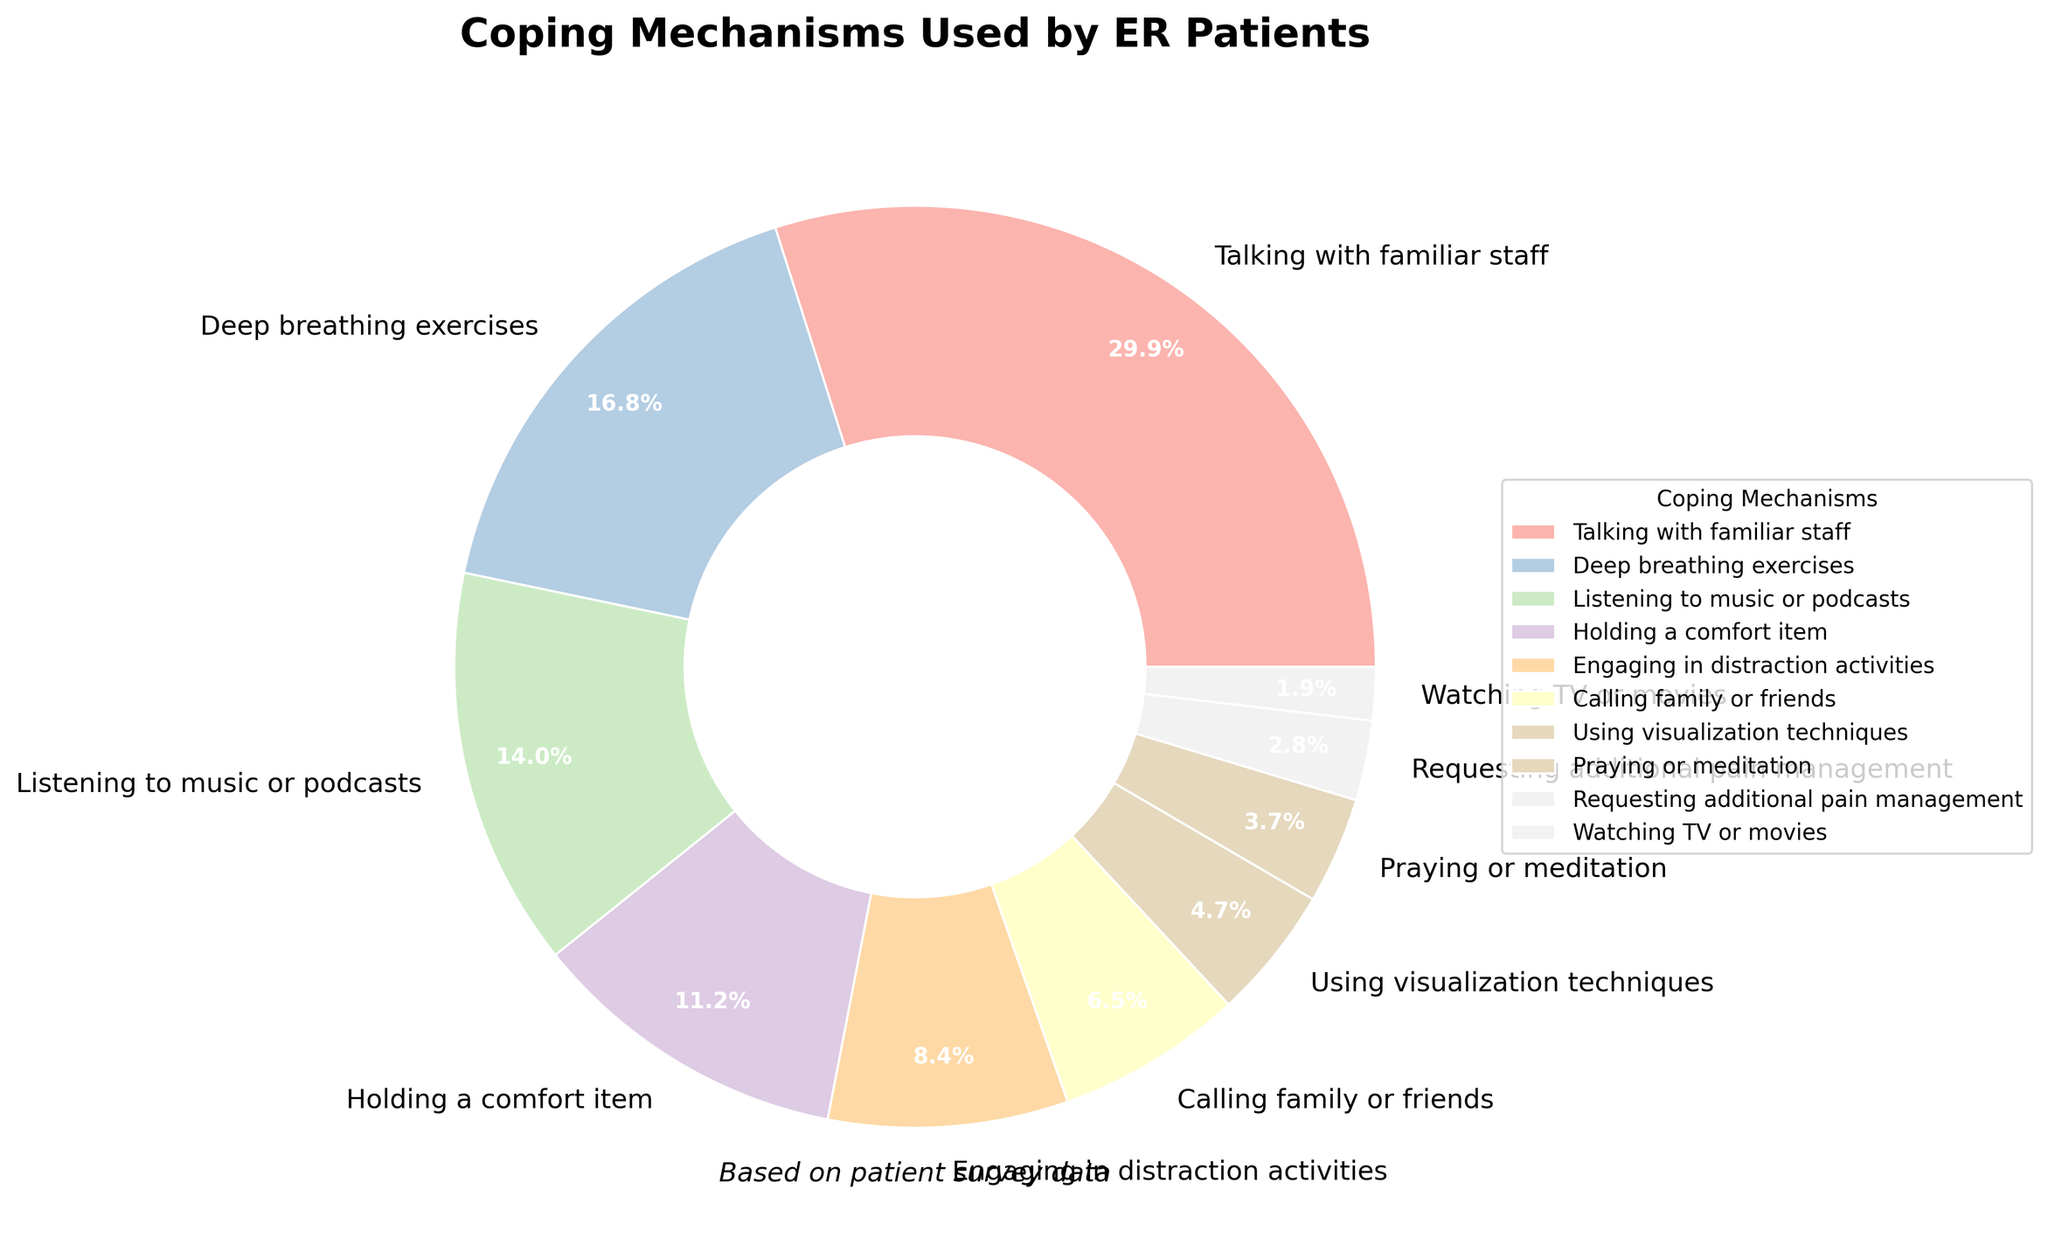What is the most common coping mechanism used by ER patients? The pie chart shows "Talking with familiar staff" occupies the largest segment, which is 32%.
Answer: Talking with familiar staff Which coping mechanism is used more, listening to music or podcasts, or engaging in distraction activities? The percentage for "Listening to music or podcasts" is 15%, whereas "Engaging in distraction activities" is 9%. 15% is greater than 9%.
Answer: Listening to music or podcasts What is the combined percentage of patients who use deep breathing exercises and holding a comfort item? The percentage for "Deep breathing exercises" is 18% and for "Holding a comfort item" is 12%. Adding them gives 18% + 12% = 30%.
Answer: 30% How much more popular is talking with familiar staff compared to praying or meditation? "Talking with familiar staff" is 32% while "Praying or meditation" is 4%. Subtracting them gives 32% - 4% = 28%.
Answer: 28% Which coping mechanism is represented by the smallest segment in the pie chart? The pie chart shows "Watching TV or movies" occupies the smallest segment, which is 2%.
Answer: Watching TV or movies How does the percentage of patients calling family or friends compare to those using visualization techniques? "Calling family or friends" has 7%, whereas "Using visualization techniques" has 5%. 7% is greater than 5%.
Answer: Calling family or friends If you combine the percentages of patients who use praying or meditation and those who request additional pain management, what is the total? "Praying or meditation" is 4% and "Requesting additional pain management" is 3%. Adding them gives 4% + 3% = 7%.
Answer: 7% What percentage of patients prefer engaging in distraction activities over calling family or friends? "Engaging in distraction activities" is 9% while "Calling family or friends" is 7%. Subtracting them gives 9% - 7% = 2%.
Answer: 2% Which coping mechanism around the chart is used by more than 10% of patients but less than 20%? The only segment that falls within this range is "Deep breathing exercises," which is 18%.
Answer: Deep breathing exercises 